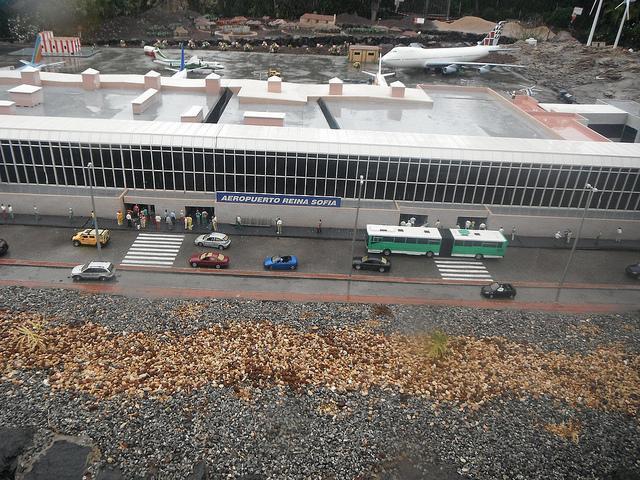What country is this location?
Pick the correct solution from the four options below to address the question.
Options: Canada, spain, mexico, france. Spain. 